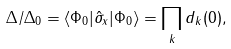Convert formula to latex. <formula><loc_0><loc_0><loc_500><loc_500>\Delta / \Delta _ { 0 } = \langle \Phi _ { 0 } | \hat { \sigma } _ { x } | \Phi _ { 0 } \rangle = \prod _ { k } d _ { k } ( 0 ) ,</formula> 